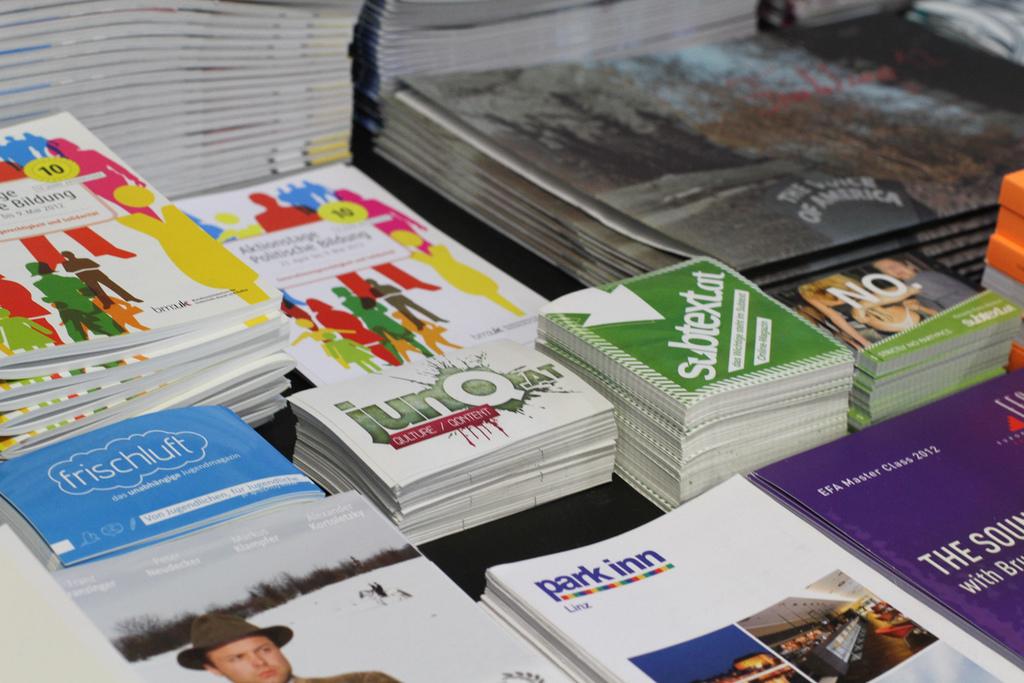What's the name of the magazine at the bottom?
Keep it short and to the point. Park inn. Is the man in the far bottom left wearing a hat?
Ensure brevity in your answer.  Answering does not require reading text in the image. 